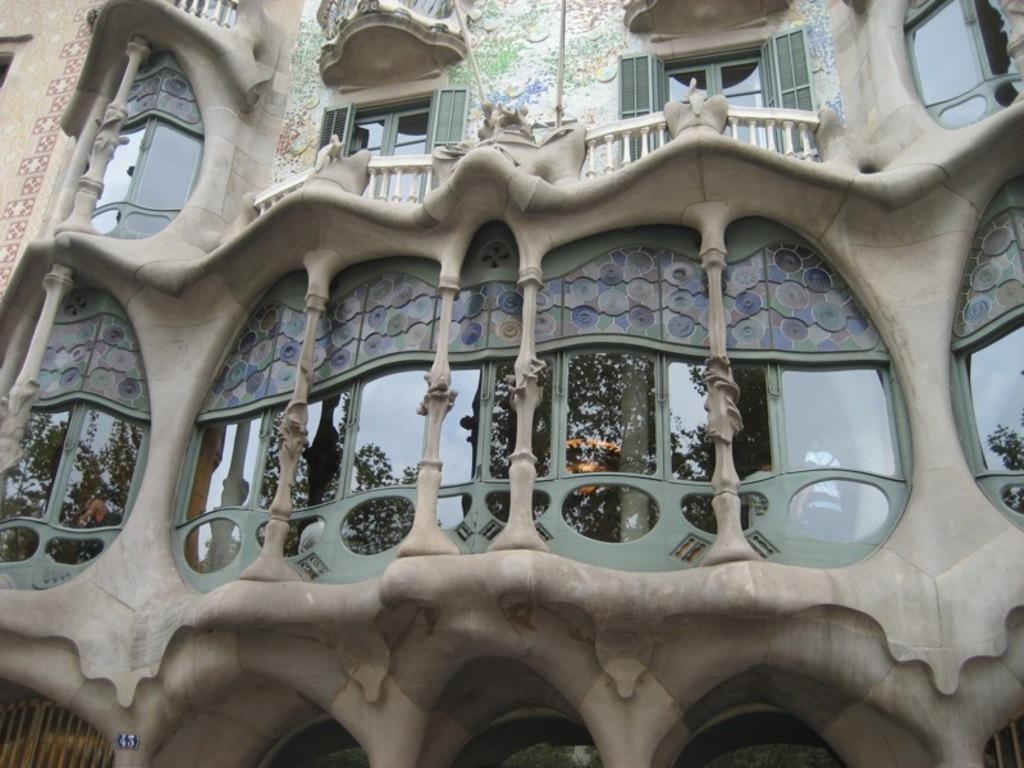Please provide a concise description of this image. In this image I can see a building along with the windows. 